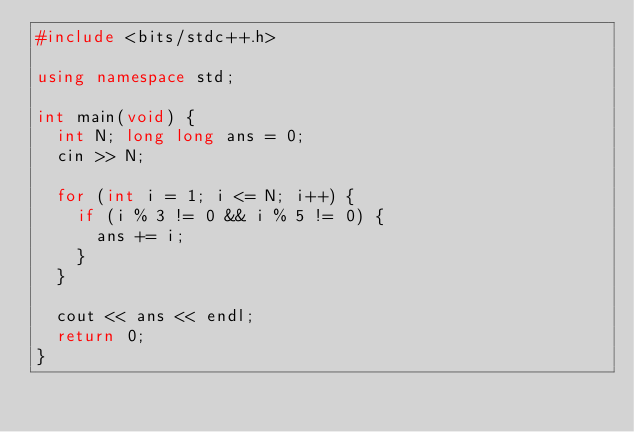<code> <loc_0><loc_0><loc_500><loc_500><_C++_>#include <bits/stdc++.h>

using namespace std;

int main(void) {
  int N; long long ans = 0;
  cin >> N;
  
  for (int i = 1; i <= N; i++) {
    if (i % 3 != 0 && i % 5 != 0) {
      ans += i;
    }
  }

  cout << ans << endl;
  return 0;
}</code> 